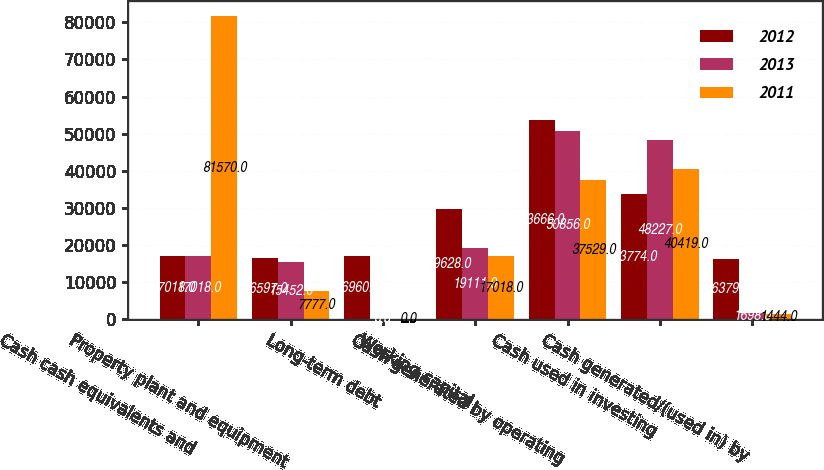<chart> <loc_0><loc_0><loc_500><loc_500><stacked_bar_chart><ecel><fcel>Cash cash equivalents and<fcel>Property plant and equipment<fcel>Long-term debt<fcel>Working capital<fcel>Cash generated by operating<fcel>Cash used in investing<fcel>Cash generated/(used in) by<nl><fcel>2012<fcel>17018<fcel>16597<fcel>16960<fcel>29628<fcel>53666<fcel>33774<fcel>16379<nl><fcel>2013<fcel>17018<fcel>15452<fcel>0<fcel>19111<fcel>50856<fcel>48227<fcel>1698<nl><fcel>2011<fcel>81570<fcel>7777<fcel>0<fcel>17018<fcel>37529<fcel>40419<fcel>1444<nl></chart> 